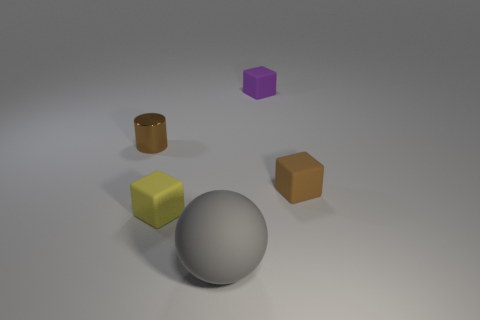Subtract 1 cubes. How many cubes are left? 2 Add 4 gray matte spheres. How many objects exist? 9 Subtract all spheres. How many objects are left? 4 Add 4 brown cylinders. How many brown cylinders exist? 5 Subtract 0 gray cylinders. How many objects are left? 5 Subtract all small yellow things. Subtract all purple things. How many objects are left? 3 Add 5 cylinders. How many cylinders are left? 6 